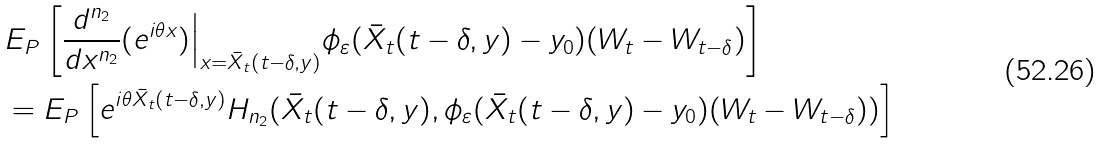Convert formula to latex. <formula><loc_0><loc_0><loc_500><loc_500>& E _ { P } \left [ \frac { d ^ { n _ { 2 } } } { d x ^ { n _ { 2 } } } ( e ^ { i \theta x } ) \Big | _ { x = \bar { X } _ { t } ( t - \delta , y ) } \phi _ { \varepsilon } ( \bar { X } _ { t } ( t - \delta , y ) - y _ { 0 } ) ( W _ { t } - W _ { t - \delta } ) \right ] \\ & = E _ { P } \left [ e ^ { i \theta \bar { X } _ { t } ( t - \delta , y ) } H _ { n _ { 2 } } ( \bar { X } _ { t } ( t - \delta , y ) , \phi _ { \varepsilon } ( \bar { X } _ { t } ( t - \delta , y ) - y _ { 0 } ) ( W _ { t } - W _ { t - \delta } ) ) \right ]</formula> 